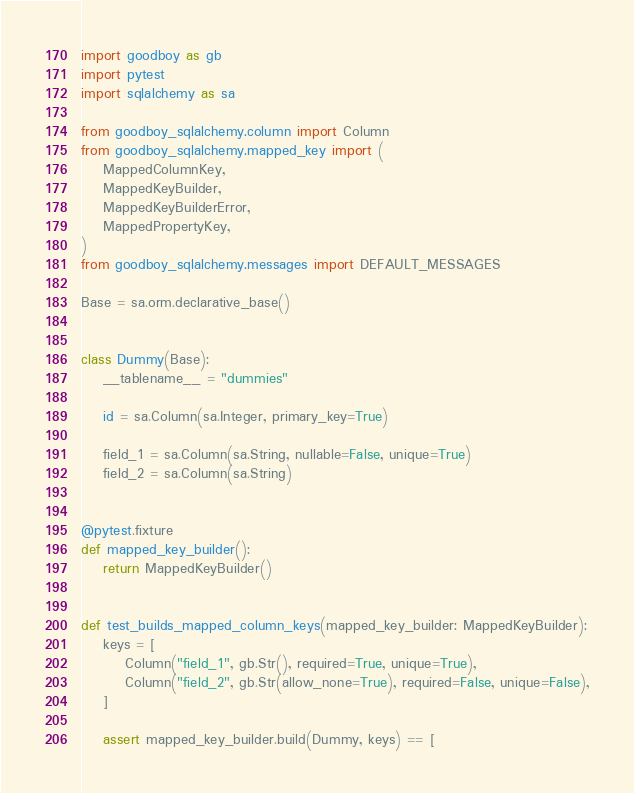Convert code to text. <code><loc_0><loc_0><loc_500><loc_500><_Python_>import goodboy as gb
import pytest
import sqlalchemy as sa

from goodboy_sqlalchemy.column import Column
from goodboy_sqlalchemy.mapped_key import (
    MappedColumnKey,
    MappedKeyBuilder,
    MappedKeyBuilderError,
    MappedPropertyKey,
)
from goodboy_sqlalchemy.messages import DEFAULT_MESSAGES

Base = sa.orm.declarative_base()


class Dummy(Base):
    __tablename__ = "dummies"

    id = sa.Column(sa.Integer, primary_key=True)

    field_1 = sa.Column(sa.String, nullable=False, unique=True)
    field_2 = sa.Column(sa.String)


@pytest.fixture
def mapped_key_builder():
    return MappedKeyBuilder()


def test_builds_mapped_column_keys(mapped_key_builder: MappedKeyBuilder):
    keys = [
        Column("field_1", gb.Str(), required=True, unique=True),
        Column("field_2", gb.Str(allow_none=True), required=False, unique=False),
    ]

    assert mapped_key_builder.build(Dummy, keys) == [</code> 